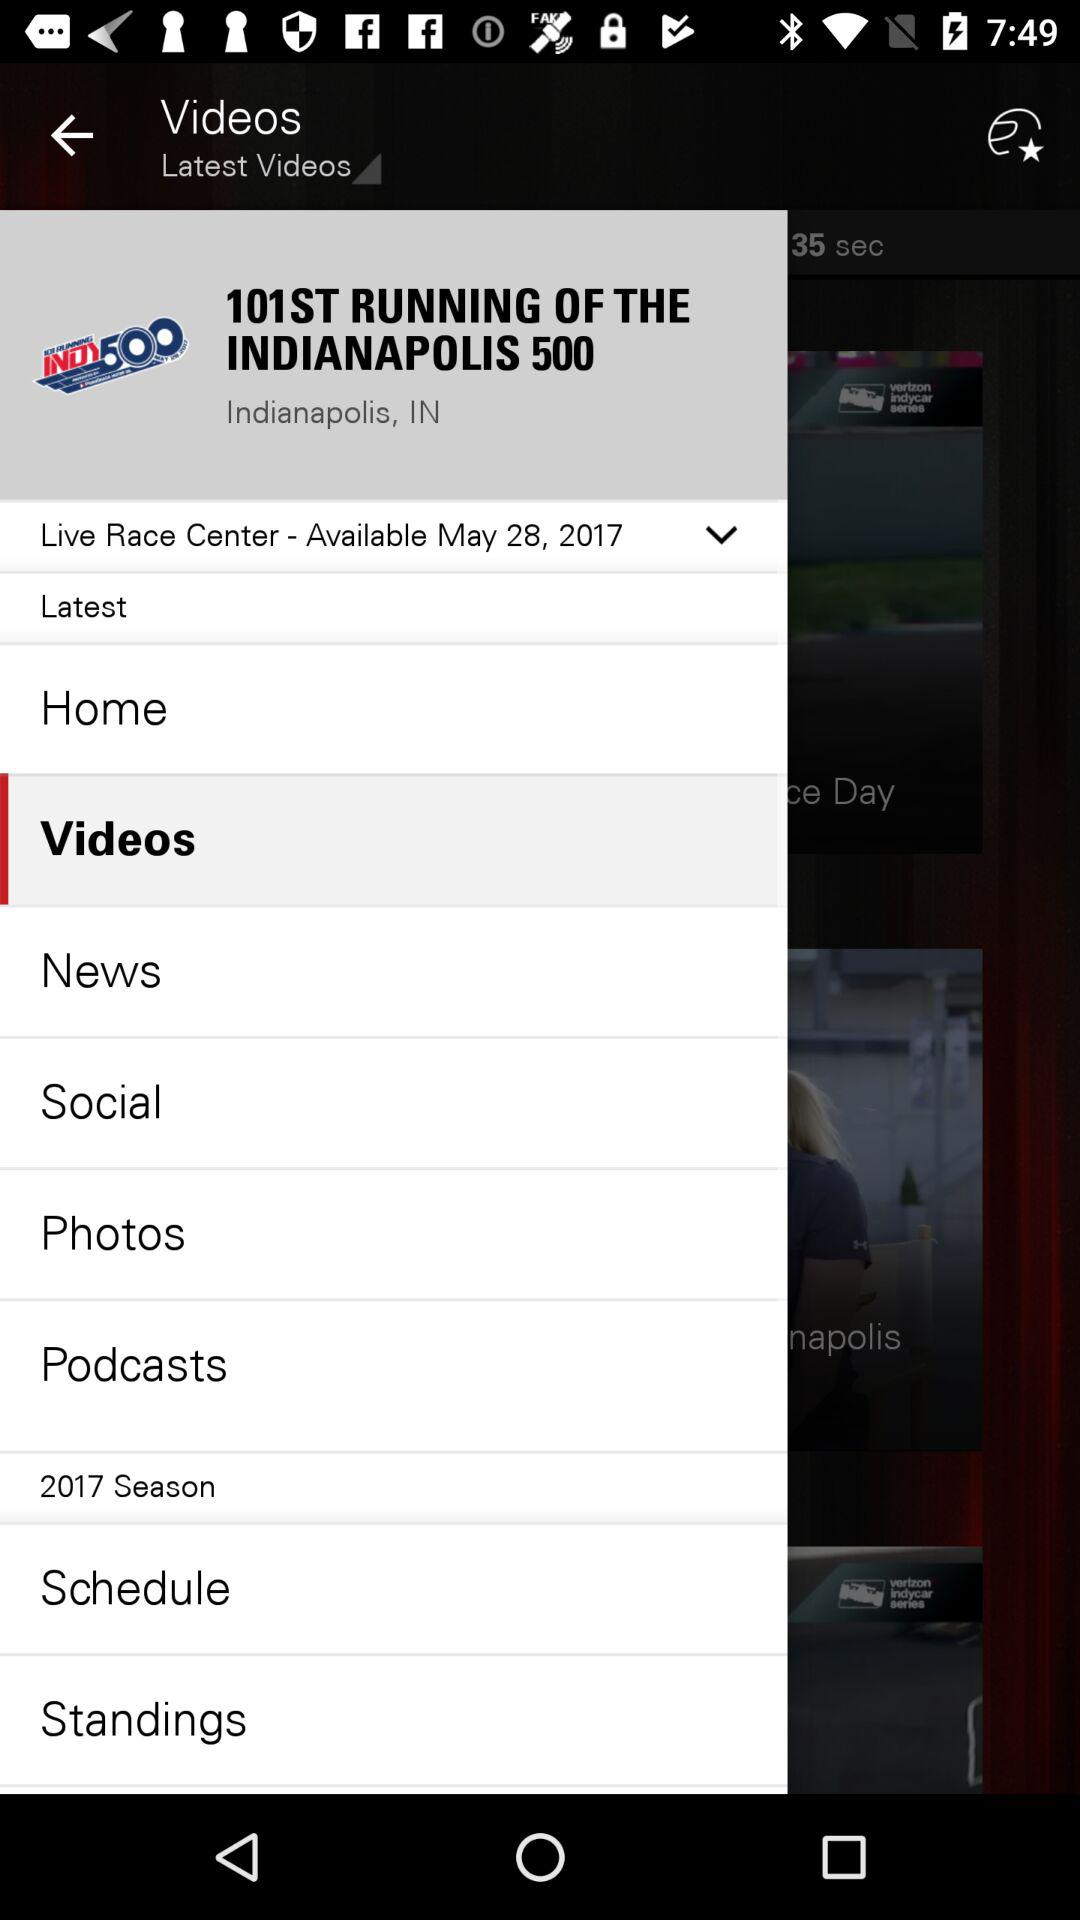"Live Race Center" is available on what date? "Live Race Center" is available on May 28, 2017. 